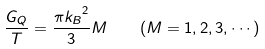Convert formula to latex. <formula><loc_0><loc_0><loc_500><loc_500>\frac { G _ { Q } } { T } = \frac { \pi { k _ { B } } ^ { 2 } } { 3 } M \quad ( M = 1 , 2 , 3 , \cdots )</formula> 